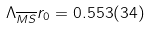<formula> <loc_0><loc_0><loc_500><loc_500>\Lambda _ { \overline { M S } } r _ { 0 } = 0 . 5 5 3 ( 3 4 )</formula> 